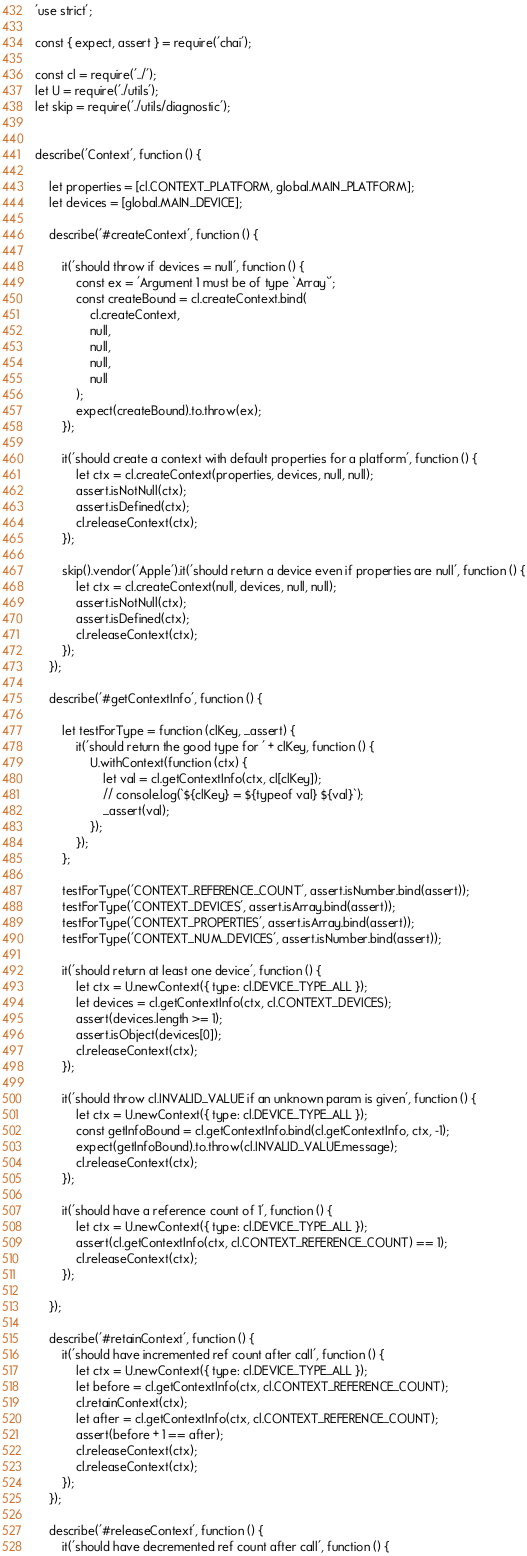Convert code to text. <code><loc_0><loc_0><loc_500><loc_500><_JavaScript_>'use strict';

const { expect, assert } = require('chai');

const cl = require('../');
let U = require('./utils');
let skip = require('./utils/diagnostic');


describe('Context', function () {

	let properties = [cl.CONTEXT_PLATFORM, global.MAIN_PLATFORM];
	let devices = [global.MAIN_DEVICE];

	describe('#createContext', function () {

		it('should throw if devices = null', function () {
			const ex = 'Argument 1 must be of type `Array`';
			const createBound = cl.createContext.bind(
				cl.createContext,
				null,
				null,
				null,
				null
			);
			expect(createBound).to.throw(ex);
		});

		it('should create a context with default properties for a platform', function () {
			let ctx = cl.createContext(properties, devices, null, null);
			assert.isNotNull(ctx);
			assert.isDefined(ctx);
			cl.releaseContext(ctx);
		});

		skip().vendor('Apple').it('should return a device even if properties are null', function () {
			let ctx = cl.createContext(null, devices, null, null);
			assert.isNotNull(ctx);
			assert.isDefined(ctx);
			cl.releaseContext(ctx);
		});
	});

	describe('#getContextInfo', function () {

		let testForType = function (clKey, _assert) {
			it('should return the good type for ' + clKey, function () {
				U.withContext(function (ctx) {
					let val = cl.getContextInfo(ctx, cl[clKey]);
					// console.log(`${clKey} = ${typeof val} ${val}`);
					_assert(val);
				});
			});
		};

		testForType('CONTEXT_REFERENCE_COUNT', assert.isNumber.bind(assert));
		testForType('CONTEXT_DEVICES', assert.isArray.bind(assert));
		testForType('CONTEXT_PROPERTIES', assert.isArray.bind(assert));
		testForType('CONTEXT_NUM_DEVICES', assert.isNumber.bind(assert));

		it('should return at least one device', function () {
			let ctx = U.newContext({ type: cl.DEVICE_TYPE_ALL });
			let devices = cl.getContextInfo(ctx, cl.CONTEXT_DEVICES);
			assert(devices.length >= 1);
			assert.isObject(devices[0]);
			cl.releaseContext(ctx);
		});

		it('should throw cl.INVALID_VALUE if an unknown param is given', function () {
			let ctx = U.newContext({ type: cl.DEVICE_TYPE_ALL });
			const getInfoBound = cl.getContextInfo.bind(cl.getContextInfo, ctx, -1);
			expect(getInfoBound).to.throw(cl.INVALID_VALUE.message);
			cl.releaseContext(ctx);
		});

		it('should have a reference count of 1', function () {
			let ctx = U.newContext({ type: cl.DEVICE_TYPE_ALL });
			assert(cl.getContextInfo(ctx, cl.CONTEXT_REFERENCE_COUNT) == 1);
			cl.releaseContext(ctx);
		});

	});

	describe('#retainContext', function () {
		it('should have incremented ref count after call', function () {
			let ctx = U.newContext({ type: cl.DEVICE_TYPE_ALL });
			let before = cl.getContextInfo(ctx, cl.CONTEXT_REFERENCE_COUNT);
			cl.retainContext(ctx);
			let after = cl.getContextInfo(ctx, cl.CONTEXT_REFERENCE_COUNT);
			assert(before + 1 == after);
			cl.releaseContext(ctx);
			cl.releaseContext(ctx);
		});
	});

	describe('#releaseContext', function () {
		it('should have decremented ref count after call', function () {</code> 